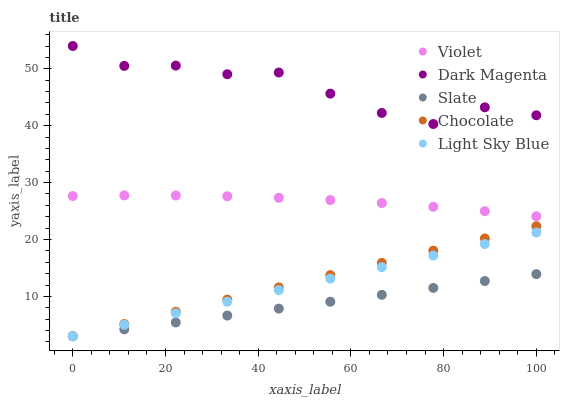Does Slate have the minimum area under the curve?
Answer yes or no. Yes. Does Dark Magenta have the maximum area under the curve?
Answer yes or no. Yes. Does Chocolate have the minimum area under the curve?
Answer yes or no. No. Does Chocolate have the maximum area under the curve?
Answer yes or no. No. Is Chocolate the smoothest?
Answer yes or no. Yes. Is Dark Magenta the roughest?
Answer yes or no. Yes. Is Dark Magenta the smoothest?
Answer yes or no. No. Is Chocolate the roughest?
Answer yes or no. No. Does Slate have the lowest value?
Answer yes or no. Yes. Does Dark Magenta have the lowest value?
Answer yes or no. No. Does Dark Magenta have the highest value?
Answer yes or no. Yes. Does Chocolate have the highest value?
Answer yes or no. No. Is Light Sky Blue less than Violet?
Answer yes or no. Yes. Is Dark Magenta greater than Light Sky Blue?
Answer yes or no. Yes. Does Chocolate intersect Light Sky Blue?
Answer yes or no. Yes. Is Chocolate less than Light Sky Blue?
Answer yes or no. No. Is Chocolate greater than Light Sky Blue?
Answer yes or no. No. Does Light Sky Blue intersect Violet?
Answer yes or no. No. 